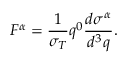<formula> <loc_0><loc_0><loc_500><loc_500>F ^ { \alpha } = \frac { 1 } { \sigma _ { T } } q ^ { 0 } \frac { d \sigma ^ { \alpha } } { d ^ { 3 } q } .</formula> 